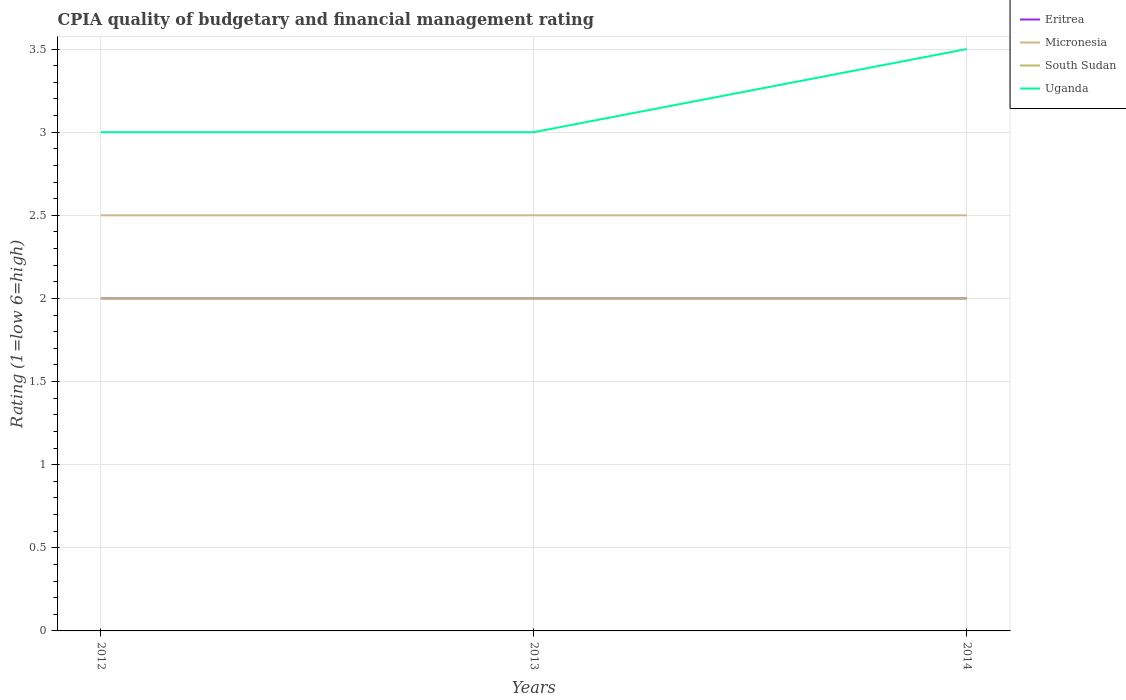How many different coloured lines are there?
Make the answer very short. 4. Does the line corresponding to Uganda intersect with the line corresponding to Eritrea?
Offer a terse response. No. Is the number of lines equal to the number of legend labels?
Offer a very short reply. Yes. What is the total CPIA rating in Eritrea in the graph?
Provide a short and direct response. 0. What is the difference between the highest and the second highest CPIA rating in Micronesia?
Provide a short and direct response. 0. What is the difference between the highest and the lowest CPIA rating in Eritrea?
Keep it short and to the point. 0. How many lines are there?
Make the answer very short. 4. How many years are there in the graph?
Provide a short and direct response. 3. What is the difference between two consecutive major ticks on the Y-axis?
Provide a succinct answer. 0.5. Are the values on the major ticks of Y-axis written in scientific E-notation?
Offer a very short reply. No. Does the graph contain any zero values?
Give a very brief answer. No. What is the title of the graph?
Your answer should be very brief. CPIA quality of budgetary and financial management rating. Does "Lesotho" appear as one of the legend labels in the graph?
Keep it short and to the point. No. What is the label or title of the X-axis?
Your answer should be compact. Years. What is the label or title of the Y-axis?
Provide a short and direct response. Rating (1=low 6=high). What is the Rating (1=low 6=high) of Micronesia in 2012?
Offer a terse response. 2.5. What is the Rating (1=low 6=high) in Micronesia in 2013?
Give a very brief answer. 2.5. What is the Rating (1=low 6=high) of South Sudan in 2014?
Your answer should be very brief. 2. Across all years, what is the maximum Rating (1=low 6=high) of South Sudan?
Give a very brief answer. 2. Across all years, what is the maximum Rating (1=low 6=high) of Uganda?
Make the answer very short. 3.5. Across all years, what is the minimum Rating (1=low 6=high) in Micronesia?
Provide a succinct answer. 2.5. What is the total Rating (1=low 6=high) of Eritrea in the graph?
Your answer should be compact. 6. What is the difference between the Rating (1=low 6=high) of South Sudan in 2012 and that in 2013?
Provide a short and direct response. 0. What is the difference between the Rating (1=low 6=high) in Micronesia in 2012 and that in 2014?
Offer a very short reply. 0. What is the difference between the Rating (1=low 6=high) of Eritrea in 2013 and that in 2014?
Your answer should be compact. 0. What is the difference between the Rating (1=low 6=high) in Uganda in 2013 and that in 2014?
Your answer should be very brief. -0.5. What is the difference between the Rating (1=low 6=high) in Eritrea in 2012 and the Rating (1=low 6=high) in Micronesia in 2013?
Keep it short and to the point. -0.5. What is the difference between the Rating (1=low 6=high) in Eritrea in 2012 and the Rating (1=low 6=high) in South Sudan in 2013?
Make the answer very short. 0. What is the difference between the Rating (1=low 6=high) in Eritrea in 2012 and the Rating (1=low 6=high) in Uganda in 2013?
Offer a very short reply. -1. What is the difference between the Rating (1=low 6=high) in Micronesia in 2012 and the Rating (1=low 6=high) in South Sudan in 2013?
Your response must be concise. 0.5. What is the difference between the Rating (1=low 6=high) of Micronesia in 2012 and the Rating (1=low 6=high) of Uganda in 2013?
Provide a short and direct response. -0.5. What is the difference between the Rating (1=low 6=high) in South Sudan in 2012 and the Rating (1=low 6=high) in Uganda in 2013?
Your answer should be compact. -1. What is the difference between the Rating (1=low 6=high) of Eritrea in 2012 and the Rating (1=low 6=high) of South Sudan in 2014?
Your response must be concise. 0. What is the difference between the Rating (1=low 6=high) in Eritrea in 2012 and the Rating (1=low 6=high) in Uganda in 2014?
Ensure brevity in your answer.  -1.5. What is the difference between the Rating (1=low 6=high) of South Sudan in 2012 and the Rating (1=low 6=high) of Uganda in 2014?
Offer a very short reply. -1.5. What is the difference between the Rating (1=low 6=high) in Eritrea in 2013 and the Rating (1=low 6=high) in Micronesia in 2014?
Make the answer very short. -0.5. What is the difference between the Rating (1=low 6=high) in Eritrea in 2013 and the Rating (1=low 6=high) in South Sudan in 2014?
Offer a very short reply. 0. What is the difference between the Rating (1=low 6=high) in Eritrea in 2013 and the Rating (1=low 6=high) in Uganda in 2014?
Your response must be concise. -1.5. What is the difference between the Rating (1=low 6=high) in Micronesia in 2013 and the Rating (1=low 6=high) in Uganda in 2014?
Your answer should be very brief. -1. What is the average Rating (1=low 6=high) in Eritrea per year?
Provide a succinct answer. 2. What is the average Rating (1=low 6=high) in Uganda per year?
Make the answer very short. 3.17. In the year 2012, what is the difference between the Rating (1=low 6=high) in Eritrea and Rating (1=low 6=high) in Uganda?
Offer a terse response. -1. In the year 2012, what is the difference between the Rating (1=low 6=high) in Micronesia and Rating (1=low 6=high) in Uganda?
Provide a short and direct response. -0.5. In the year 2012, what is the difference between the Rating (1=low 6=high) of South Sudan and Rating (1=low 6=high) of Uganda?
Your response must be concise. -1. In the year 2013, what is the difference between the Rating (1=low 6=high) in Micronesia and Rating (1=low 6=high) in South Sudan?
Offer a terse response. 0.5. In the year 2013, what is the difference between the Rating (1=low 6=high) of Micronesia and Rating (1=low 6=high) of Uganda?
Provide a short and direct response. -0.5. In the year 2014, what is the difference between the Rating (1=low 6=high) in Eritrea and Rating (1=low 6=high) in South Sudan?
Ensure brevity in your answer.  0. In the year 2014, what is the difference between the Rating (1=low 6=high) in South Sudan and Rating (1=low 6=high) in Uganda?
Give a very brief answer. -1.5. What is the ratio of the Rating (1=low 6=high) in Micronesia in 2012 to that in 2013?
Offer a very short reply. 1. What is the ratio of the Rating (1=low 6=high) of Uganda in 2012 to that in 2013?
Offer a very short reply. 1. What is the ratio of the Rating (1=low 6=high) in Eritrea in 2012 to that in 2014?
Your answer should be compact. 1. What is the ratio of the Rating (1=low 6=high) of Micronesia in 2012 to that in 2014?
Keep it short and to the point. 1. What is the ratio of the Rating (1=low 6=high) in Uganda in 2012 to that in 2014?
Give a very brief answer. 0.86. What is the difference between the highest and the second highest Rating (1=low 6=high) in Eritrea?
Provide a short and direct response. 0. What is the difference between the highest and the second highest Rating (1=low 6=high) of Micronesia?
Keep it short and to the point. 0. What is the difference between the highest and the second highest Rating (1=low 6=high) in Uganda?
Your answer should be very brief. 0.5. What is the difference between the highest and the lowest Rating (1=low 6=high) in Micronesia?
Ensure brevity in your answer.  0. What is the difference between the highest and the lowest Rating (1=low 6=high) of South Sudan?
Make the answer very short. 0. What is the difference between the highest and the lowest Rating (1=low 6=high) of Uganda?
Give a very brief answer. 0.5. 